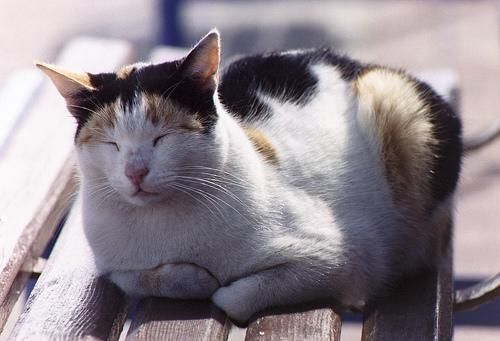Find and count the total number of distinct objects that make up the calico cat in the image. There are 13 distinct objects that make up the calico cat in the image. What is the main interaction between subjects in the image, if any? The main interaction is the cat lying on a wooden bench, with no other subjects interacting with it. How many descriptions are there mentioning the cat's various facial features? There are 15 descriptions mentioning the cat's various facial features. Briefly describe the sentiment evoked by the image. The image evokes a sentiment of peace and relaxation due to the sleeping cat. Examine the image and describe a more complex reasoning task that can be performed based on its content. A more complex reasoning task could involve predicting the cat's behavior depending on potential disturbances or changes within its immediate environment. Assess the overall quality of the image with regard to focus and clarity. The image quality appears to be sharp and well-focused, providing clear details of the cat and its surroundings. Please give a short description of the main subject in the image. A sleeping white cat with brown and black spots, brown ears, and white whiskers, lying on a wooden bench. What color are the cat's ears and what color is the cat's tail? The cat's ears are brown, the tail color is unclear Is the image in color or black and white? Color Can you spot a cat with blue whiskers at X:42 Y:156? The given coordinates are for a cat with whiskers, but the color is not mentioned. Assuming they are white or similar, this is misleading as it suggests the cat has blue whiskers. Describe the different colors of the cat's ears in the image. Both ears are brown Does the image show a cat on a wooden bench, a cat on a sofa, or a cat on a bed? A cat on a wooden bench Can you find a human holding the cat at X:14 Y:9? The given coordinates are for a sleeping cat, with no mention of a human. This is misleading as it suggests there is a human in the image holding the cat. Are the cat's mouth open or closed in the image? Closed What type of cat is depicted in the image? Calico cat Describe the relative size of the cat in relation to the wooden bench in the image. The cat is taking up a significant portion of the bench. How many paws are visible and what color are they? Two white paws are visible How many whiskers does the cat have on each side? More than a few, precise number unclear Can you find the orange ear of the cat at X:33 Y:54? The coordinates given are for a brown ear, not an orange one. This is misleading as it suggests the cat has an orange ear. What is the position of the cat on the bench: left, center, or right? Center List the facial features that you can identify in the image. White eyes, pink nose, white whiskers, closed mouth How many colors are the cat's eyes, and what are those colors? The cat's eyes are one color - white Detect the overall fur color of the cat in the image. White with black and brown spots Which part of the cat is closest to a part of the wooden bench? The cat's paws Is the cat's eye located at X:150 Y:124 and green in color? The given coordinates are for a white cat's eye, not green. This is misleading as it suggests the cat's eye is green. Is there a cat jumping up from the wooden bench at X:0 Y:34? The given coordinates are for a cat on a wooden bench, not jumping up from it. This is misleading as it suggests the cat is in a different action. Is the cat's tail visible and curled around its body at X:31 Y:26? There is no mention of a cat's tail in the given coordinates. This is misleading as it suggests the cat's tail can be seen in a specific pose. Which side of the cat seems to be in contact with the wooden bench: back, belly, or both? Both back and belly are in contact with the bench What is the color of the cat's eye in the image? White What is the state of consciousness of the cat in the image? Sleeping Identify the material of the surface the cat is laying on. Brown wooden bench Is the cat's nose pink, brown, or black? Pink 